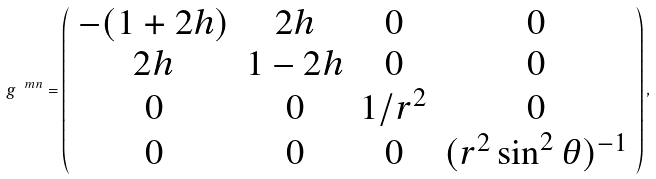Convert formula to latex. <formula><loc_0><loc_0><loc_500><loc_500>g ^ { \ m n } = \left ( \begin{array} { c c c c } - ( 1 + 2 h ) & 2 h & 0 & 0 \\ 2 h & 1 - 2 h & 0 & 0 \\ 0 & 0 & 1 / r ^ { 2 } & 0 \\ 0 & 0 & 0 & ( r ^ { 2 } \sin ^ { 2 } \theta ) ^ { - 1 } \end{array} \right ) ,</formula> 